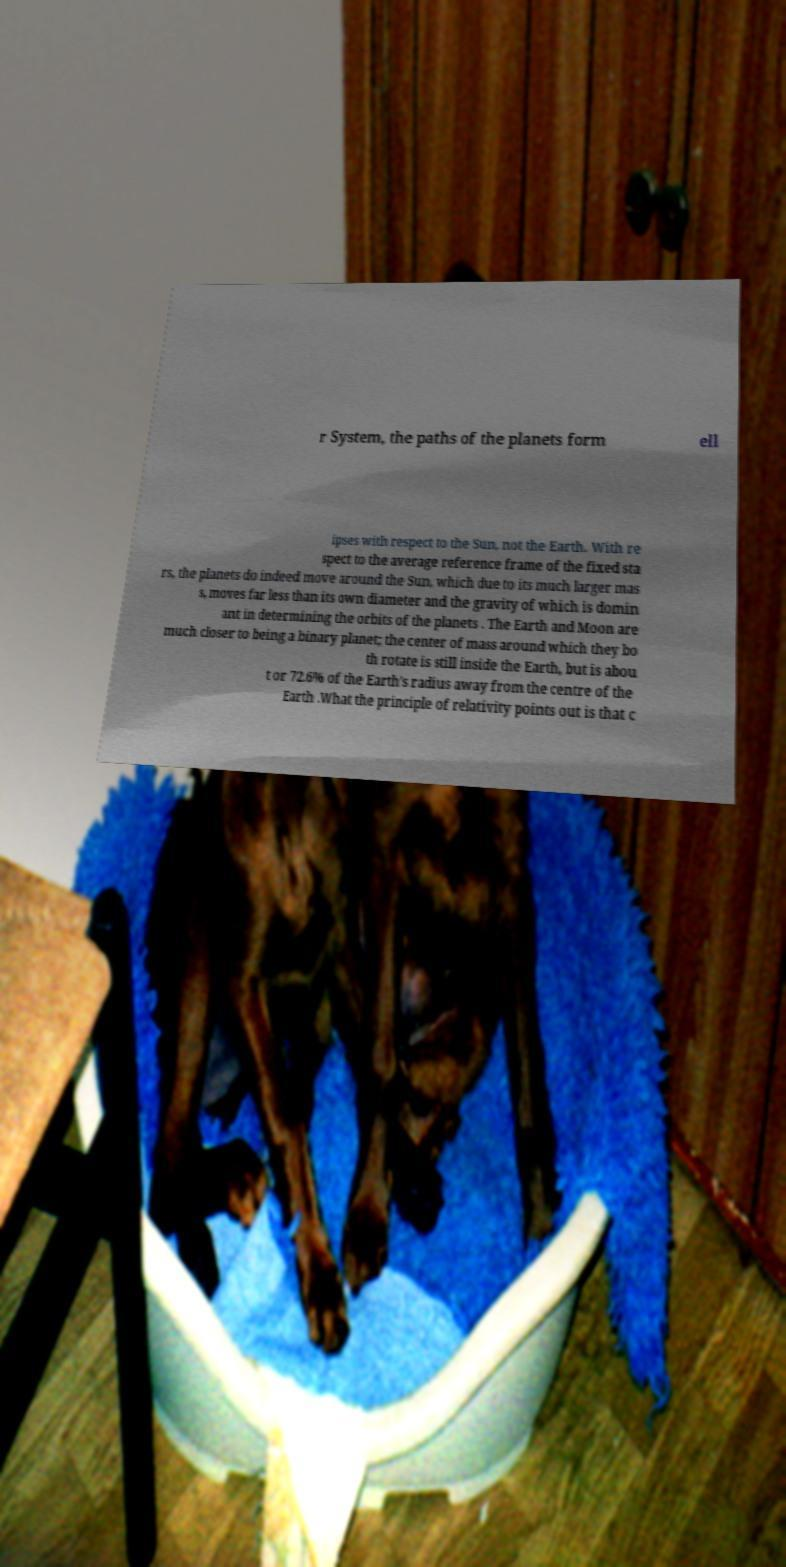Please identify and transcribe the text found in this image. r System, the paths of the planets form ell ipses with respect to the Sun, not the Earth. With re spect to the average reference frame of the fixed sta rs, the planets do indeed move around the Sun, which due to its much larger mas s, moves far less than its own diameter and the gravity of which is domin ant in determining the orbits of the planets . The Earth and Moon are much closer to being a binary planet; the center of mass around which they bo th rotate is still inside the Earth, but is abou t or 72.6% of the Earth's radius away from the centre of the Earth .What the principle of relativity points out is that c 